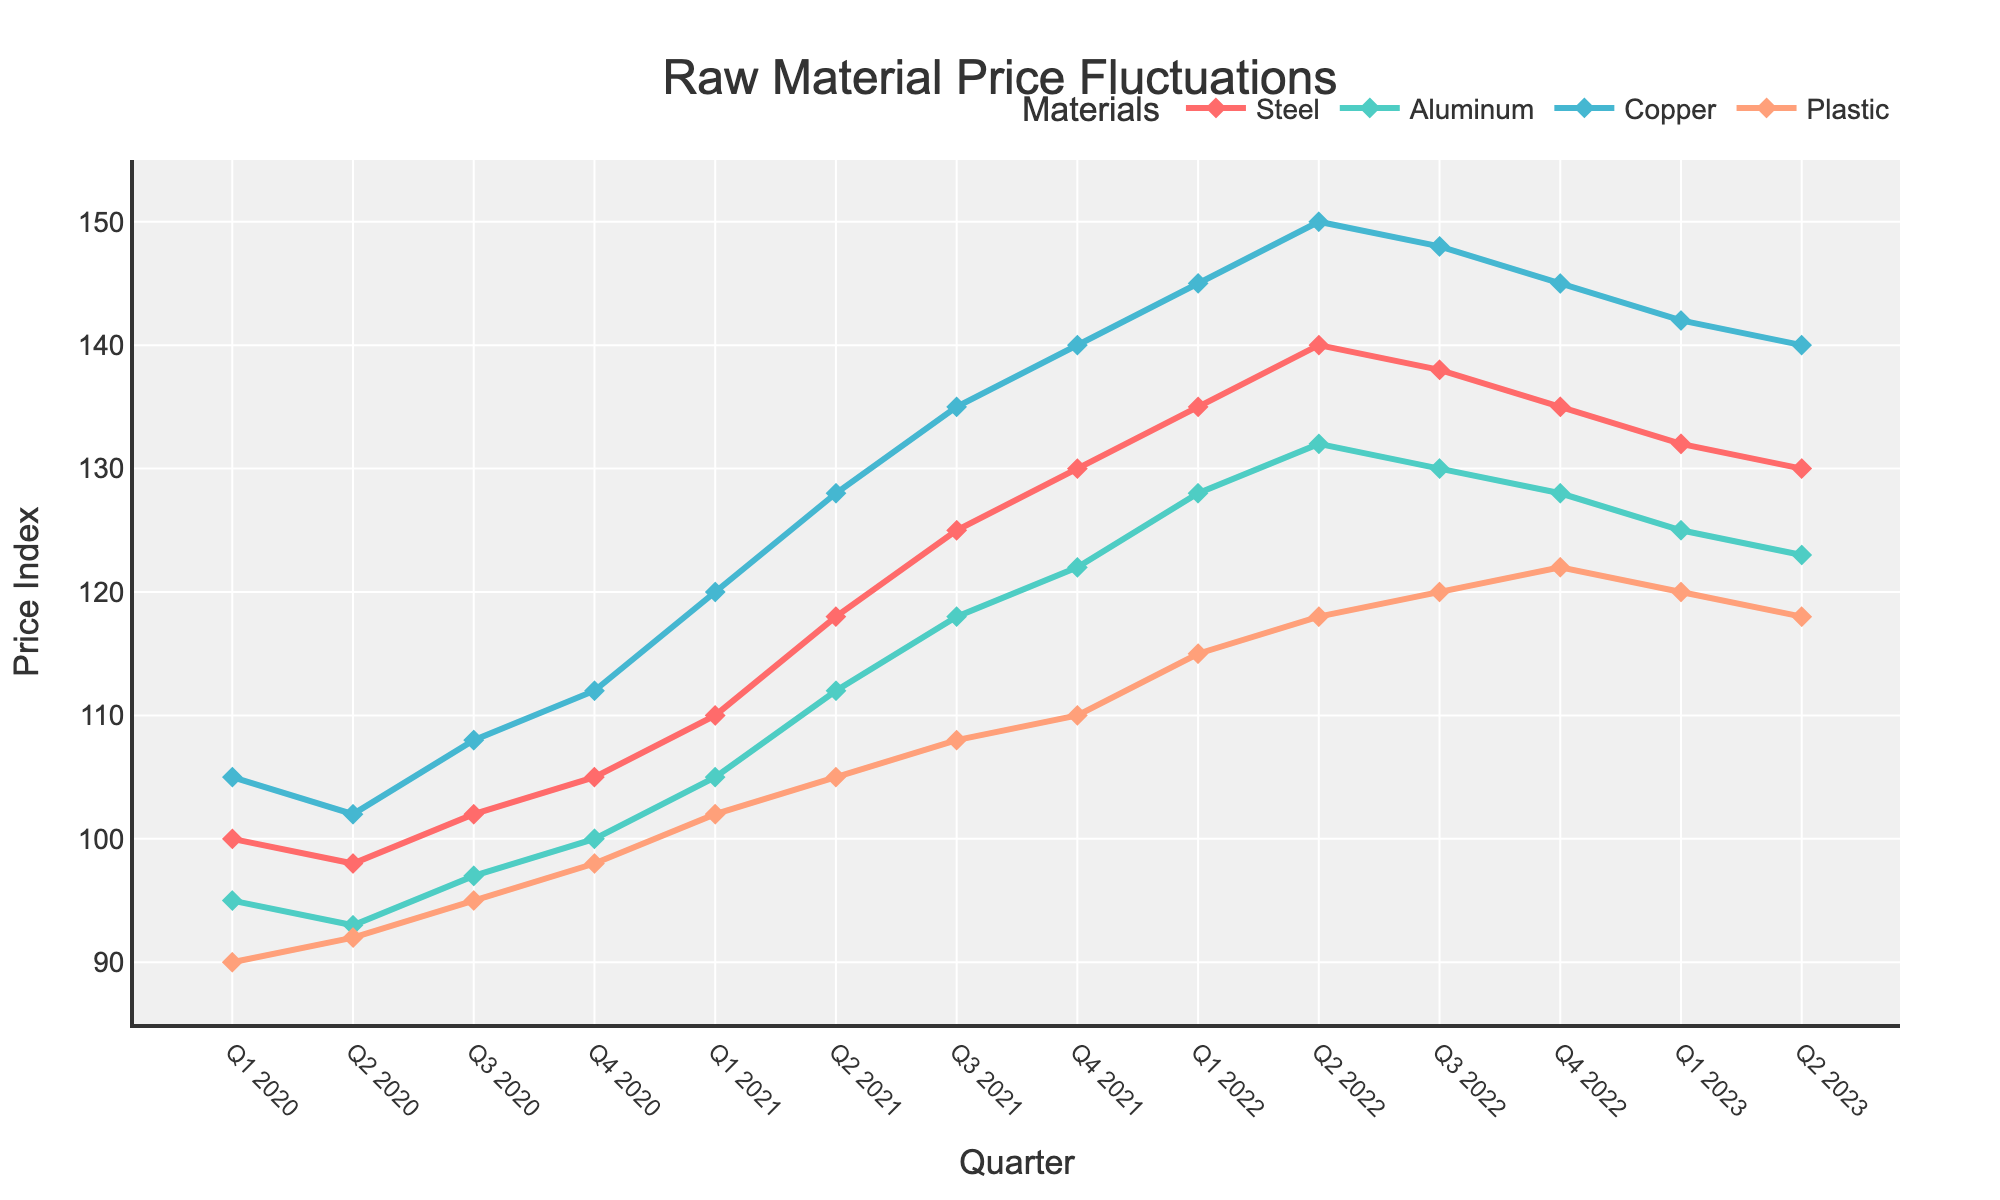What's the overall trend in the price of Steel between Q1 2020 and Q2 2023? The price of Steel has shown an upward trend from Q1 2020 to Q2 2023. It started at 100 in Q1 2020 and reached 130 by Q2 2023, with some fluctuations in between.
Answer: Upward trend Which material had the highest price increase from Q1 2020 to Q2 2023? To determine the highest price increase, find the difference between the Q2 2023 price and the Q1 2020 price for each material. Steel: 130 - 100 = 30, Aluminum: 123 - 95 = 28, Copper: 140 - 105 = 35, Plastic: 118 - 90 = 28. Copper had the highest price increase of 35.
Answer: Copper Did any material experience a price decrease at any point? Observing the plot, Aluminum's price decreased slightly from Q2 2022 to Q4 2022 and again from Q1 2023 to Q2 2023.
Answer: Aluminum Between Q2 2022 and Q2 2023, which material's price remained the most stable? Stability can be assessed by minimal fluctuations. Plastic showed the least amount of change, rising only slightly from 118 to 120 and then slightly decreasing back to 118.
Answer: Plastic What was the price of Copper in Q2 2021, and how does it compare to the price in Q2 2023? The price of Copper in Q2 2021 was 128 and in Q2 2023 was 140. The price increased by 12.
Answer: Increased by 12 How does the price change of Aluminum from Q1 2020 to Q4 2020 compare to the price change of Steel in the same period? Aluminum changed from 95 to 100 (an increase of 5), while Steel changed from 100 to 105 (an increase of 5). Both materials increased by the same amount (5).
Answer: Same increase What's the average price of Plastic throughout 2022? The prices of Plastic in 2022 were: Q1 115, Q2 118, Q3 120, Q4 122. Average = (115 + 118 + 120 + 122) / 4 = 475 / 4 = 118.75.
Answer: 118.75 In which quarter did the price of Steel peak, and what was the price? The price of Steel peaked in Q2 2022 at 140.
Answer: Q2 2022, 140 During which quarter in 2021 did the price of Aluminum surpass 110 for the first time? Aluminum surpassed 110 for the first time in Q2 2021, where its price was 112.
Answer: Q2 2021 